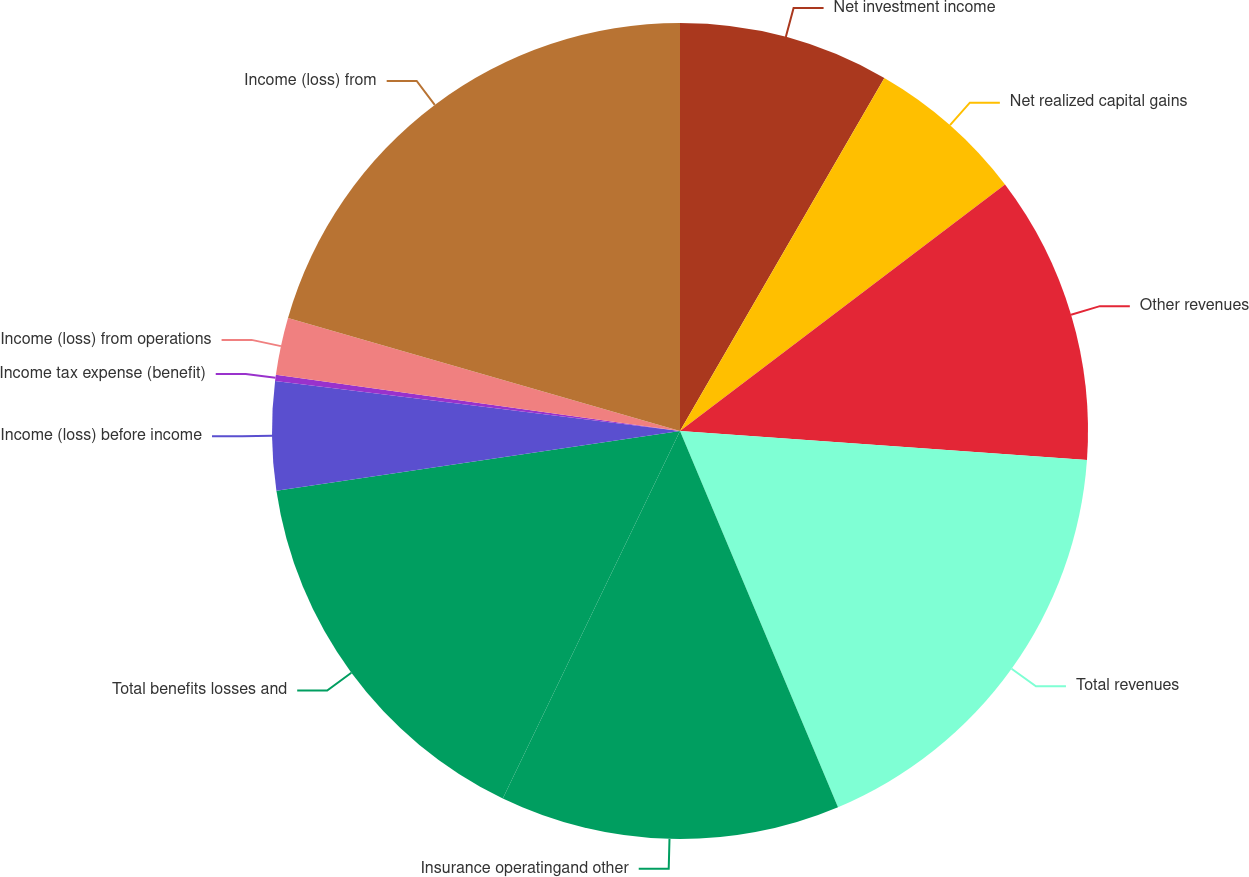<chart> <loc_0><loc_0><loc_500><loc_500><pie_chart><fcel>Net investment income<fcel>Net realized capital gains<fcel>Other revenues<fcel>Total revenues<fcel>Insurance operatingand other<fcel>Total benefits losses and<fcel>Income (loss) before income<fcel>Income tax expense (benefit)<fcel>Income (loss) from operations<fcel>Income (loss) from<nl><fcel>8.35%<fcel>6.32%<fcel>11.46%<fcel>17.54%<fcel>13.48%<fcel>15.51%<fcel>4.3%<fcel>0.24%<fcel>2.27%<fcel>20.53%<nl></chart> 